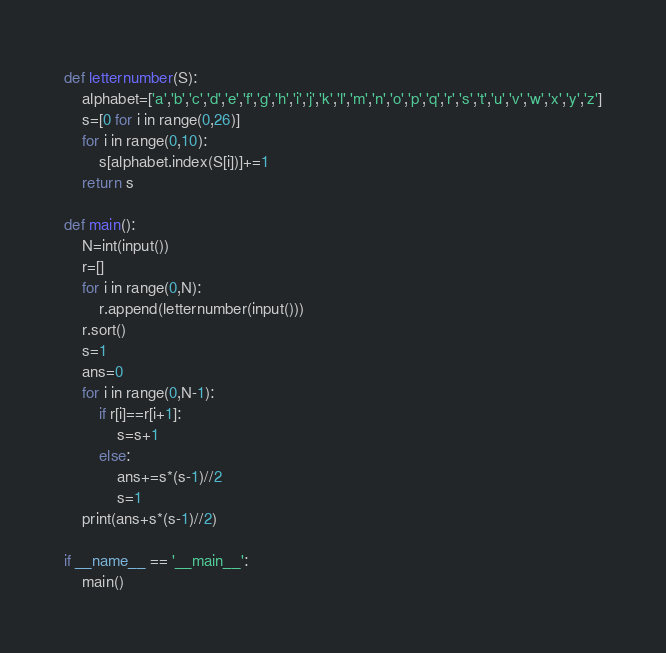<code> <loc_0><loc_0><loc_500><loc_500><_Python_>def letternumber(S):
    alphabet=['a','b','c','d','e','f','g','h','i','j','k','l','m','n','o','p','q','r','s','t','u','v','w','x','y','z']
    s=[0 for i in range(0,26)]
    for i in range(0,10):
        s[alphabet.index(S[i])]+=1
    return s

def main():
    N=int(input())
    r=[]
    for i in range(0,N):
        r.append(letternumber(input()))
    r.sort()
    s=1
    ans=0
    for i in range(0,N-1):
        if r[i]==r[i+1]:
            s=s+1
        else:
            ans+=s*(s-1)//2
            s=1
    print(ans+s*(s-1)//2)

if __name__ == '__main__':
    main()</code> 